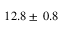<formula> <loc_0><loc_0><loc_500><loc_500>1 2 . 8 \pm \, 0 . 8</formula> 